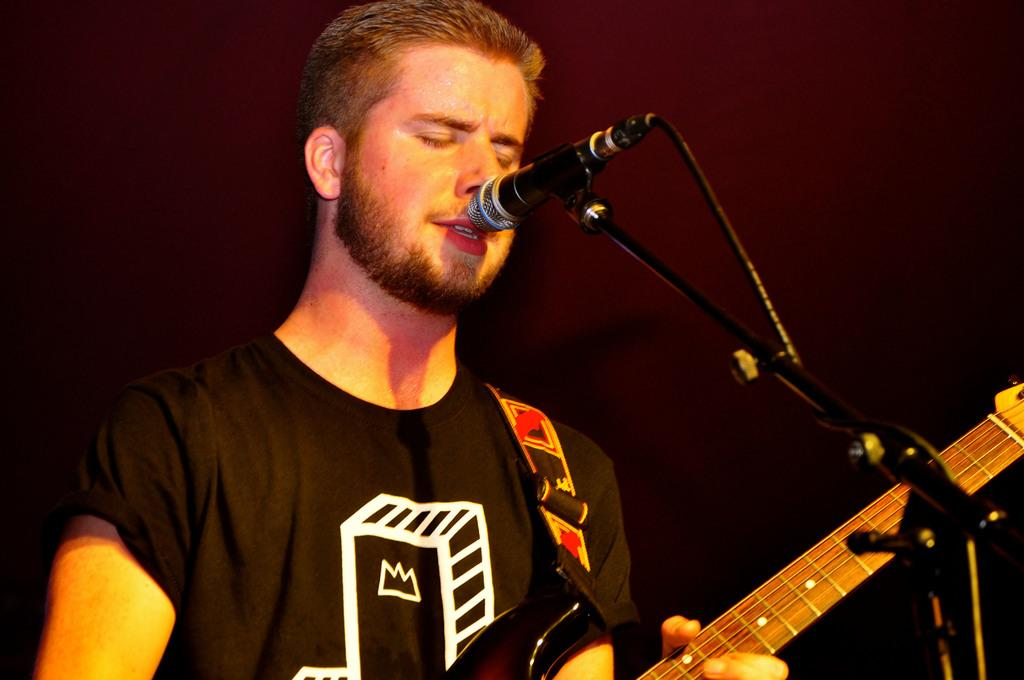What is the man in the image doing? The man is singing in the image. What is the man holding while singing? The man is holding a microphone. What musical instrument is the man playing? The man is playing a guitar. How many sheep are visible in the image? There are no sheep present in the image. What trick is the man performing with his tongue while playing the guitar? The man is not performing any tricks with his tongue in the image; he is simply singing and playing the guitar. 